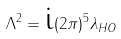Convert formula to latex. <formula><loc_0><loc_0><loc_500><loc_500>\Lambda ^ { 2 } = \text {i} ( 2 \pi ) ^ { 5 } \lambda _ { H O }</formula> 